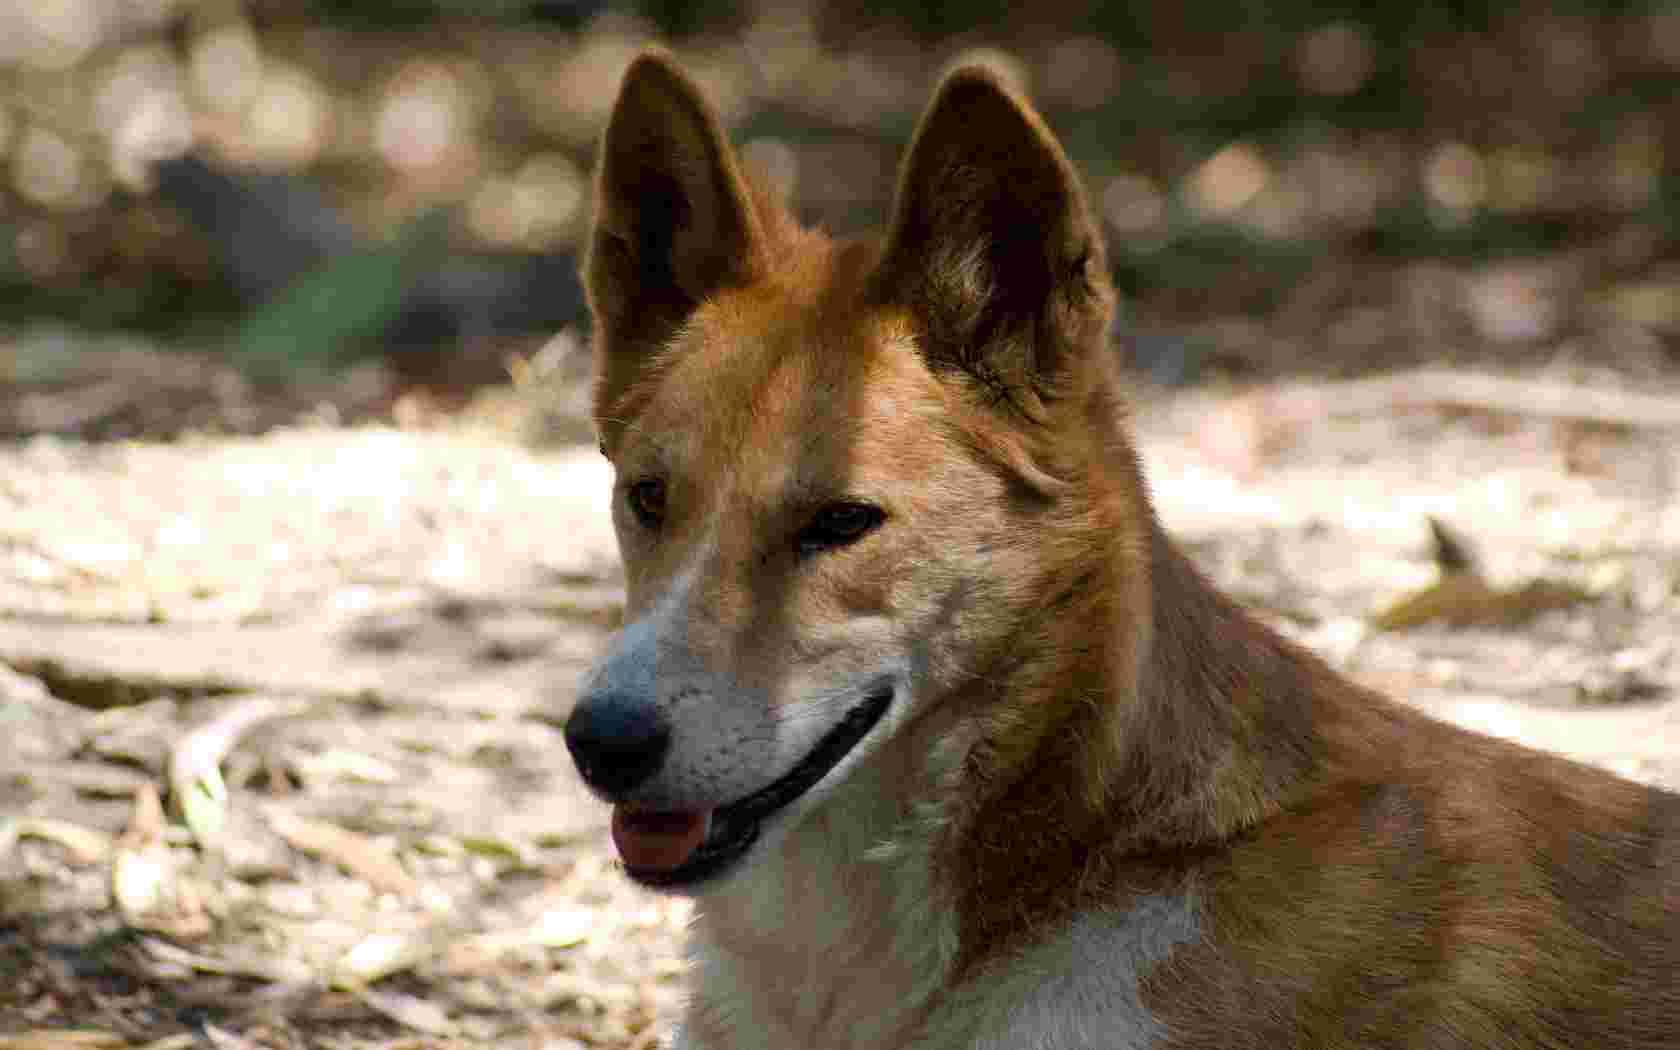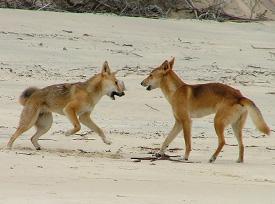The first image is the image on the left, the second image is the image on the right. Evaluate the accuracy of this statement regarding the images: "An image shows a wild dog grasping part of another animal with its mouth.". Is it true? Answer yes or no. No. The first image is the image on the left, the second image is the image on the right. For the images displayed, is the sentence "One of the photos shows a wild dog biting another animal." factually correct? Answer yes or no. No. 